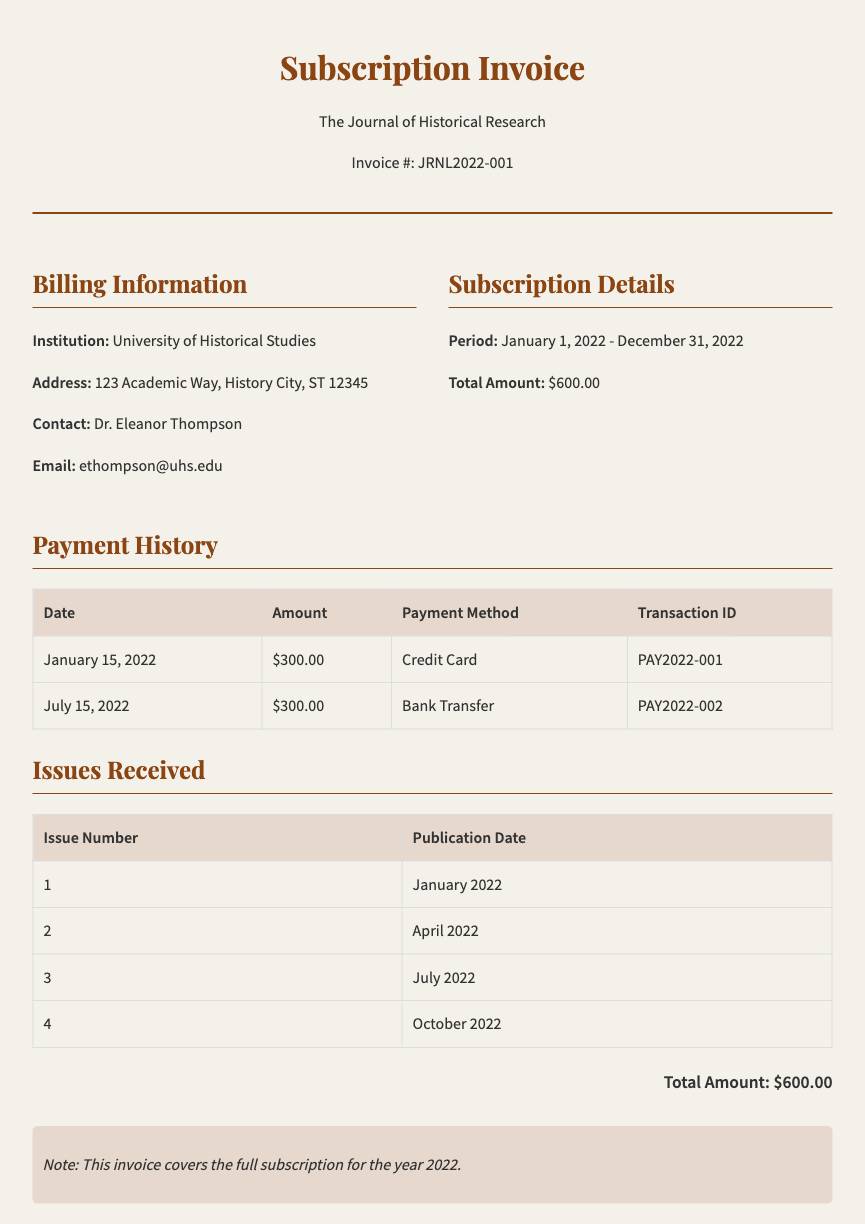What is the invoice number? The invoice number is provided in the header section of the document, which is JRNL2022-001.
Answer: JRNL2022-001 Who is the contact person for the institution? The contact person is listed in the billing information section, which identifies Dr. Eleanor Thompson.
Answer: Dr. Eleanor Thompson What is the total amount of the subscription? The total amount is stated in the subscription details, which is $600.00.
Answer: $600.00 When was the first payment made? The first payment date is found in the payment history table, which is January 15, 2022.
Answer: January 15, 2022 How many issues were received during the subscription period? The issues received are listed in the issues received table, and four issues are mentioned.
Answer: 4 What payment methods were used for the transactions? The payment methods are provided in the payment history table, which includes Credit Card and Bank Transfer.
Answer: Credit Card, Bank Transfer What is the publication date of the second issue? The publication date for the second issue is found in the issues received table, which is April 2022.
Answer: April 2022 What does the note at the bottom of the invoice state? The note at the bottom clarifies that the invoice covers the full subscription for the year 2022.
Answer: This invoice covers the full subscription for the year 2022 